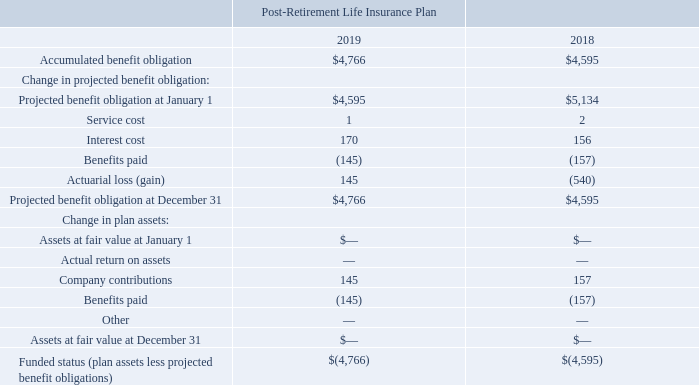NOTES TO CONSOLIDATED FINANCIAL STATEMENTS (in thousands, except for share and per share data)
NOTE 6 — Retirement Plans
We have a number of noncontributory defined benefit pension plans ("pension plans") covering approximately 3% of our active employees. Pension plans covering salaried employees provide pension benefits that are based on the employees´ years of service and compensation prior to retirement. Pension plans covering hourly employees generally provide benefits of stated amounts for each year of service.
We also provide post-retirement life insurance benefits for certain retired employees. Domestic employees who were hired prior to 1982 and certain former union employees are eligible for life insurance benefits upon retirement. We fund life insurance benefits through term life insurance policies and intend to continue funding all of the premiums on a pay-as-you-go basis.
We recognize the funded status of a benefit plan in our consolidated balance sheets. The funded status is measured as the difference between plan assets at fair value and the projected benefit obligation. We also recognize, as a component of other comprehensive earnings, net of tax, the gains or losses and prior service costs or credits that arise during the period but are not recognized as components of net periodic benefit/cost.
The measurement dates for the pension plans for our U.S. and non-U.S. locations were December 31, 2019, and 2018.
During 2017, we offered certain former vested employees in our U.S. pension plan a one-time option to receive a lump sum distribution of their benefits from pension plan assets. The pension plan made approximately $23,912 in lump sum payments to settle its obligation to these participants. These settlement payments decreased the projected benefit obligation and plan assets by $23,912, and resulted in a non-cash settlement charge of $13,476 related to unrecognized net actuarial losses that were previously included in accumulated other comprehensive loss. The measurement date of this settlement was December 31, 2017.
In February 2020, the CTS Board of Directors authorized and empowered management to explore termination of our U.S. based pension plans at management's discretion, subject to certain conditions. Management has not yet made a final decision on whether to pursue a plan termination and the potential timing thereof.
The measurement dates for the post-retirement life insurance plan were December 31, 2019, and 2018. The following table provides a reconciliation of benefit obligation, plan assets, and the funded status of the post-retirement life insurance plan at those measurement dates.
How does the company provide pension plans that cover salaries employees? Provide pension benefits that are based on the employees´ years of service and compensation prior to retirement. What did the CTS Board of Directors authorize in February 2020? Authorized and empowered management to explore termination of our u.s. based pension plans at management's discretion, subject to certain conditions. What was the accumulated benefit obligation in 2019?
Answer scale should be: thousand. 4,766. What was the change in the Projected benefit obligation at January 1 between 2018 and 2019?
Answer scale should be: thousand. 4,595-5,134
Answer: -539. How many years did the Interest cost exceed $150 thousand? 2019##2018
Answer: 2. What was the percentage change in company contributions between 2018 and 2019?
Answer scale should be: percent. (145-157)/157
Answer: -7.64. 